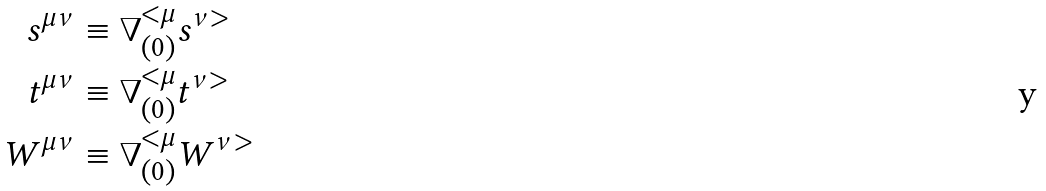Convert formula to latex. <formula><loc_0><loc_0><loc_500><loc_500>s ^ { \mu \nu } & \equiv \nabla ^ { < \mu } _ { ( 0 ) } s ^ { \nu > } \\ t ^ { \mu \nu } & \equiv \nabla ^ { < \mu } _ { ( 0 ) } t ^ { \nu > } \\ W ^ { \mu \nu } & \equiv \nabla ^ { < \mu } _ { ( 0 ) } W ^ { \nu > }</formula> 